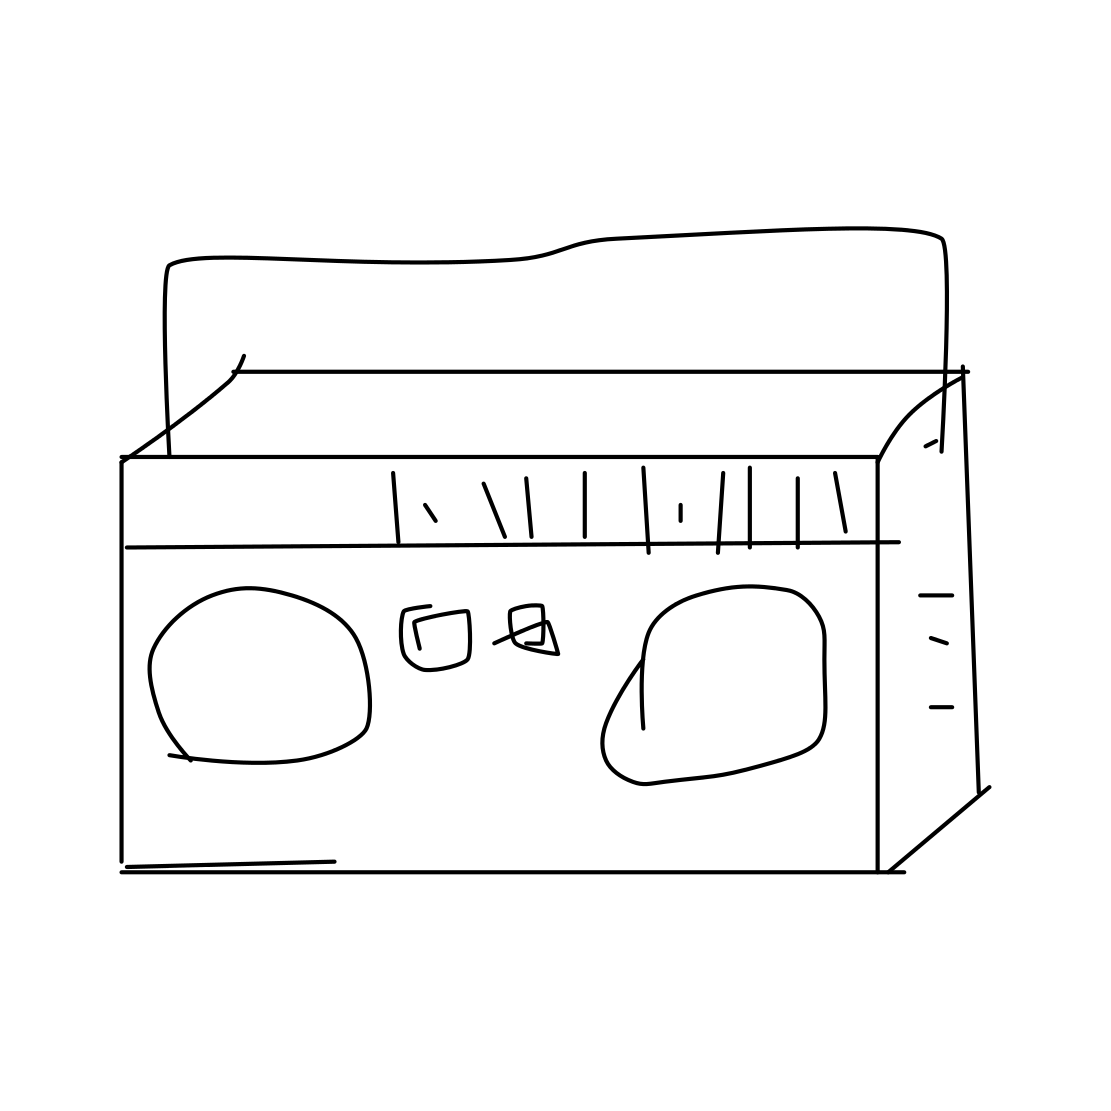In the scene, is a suv in it? No 